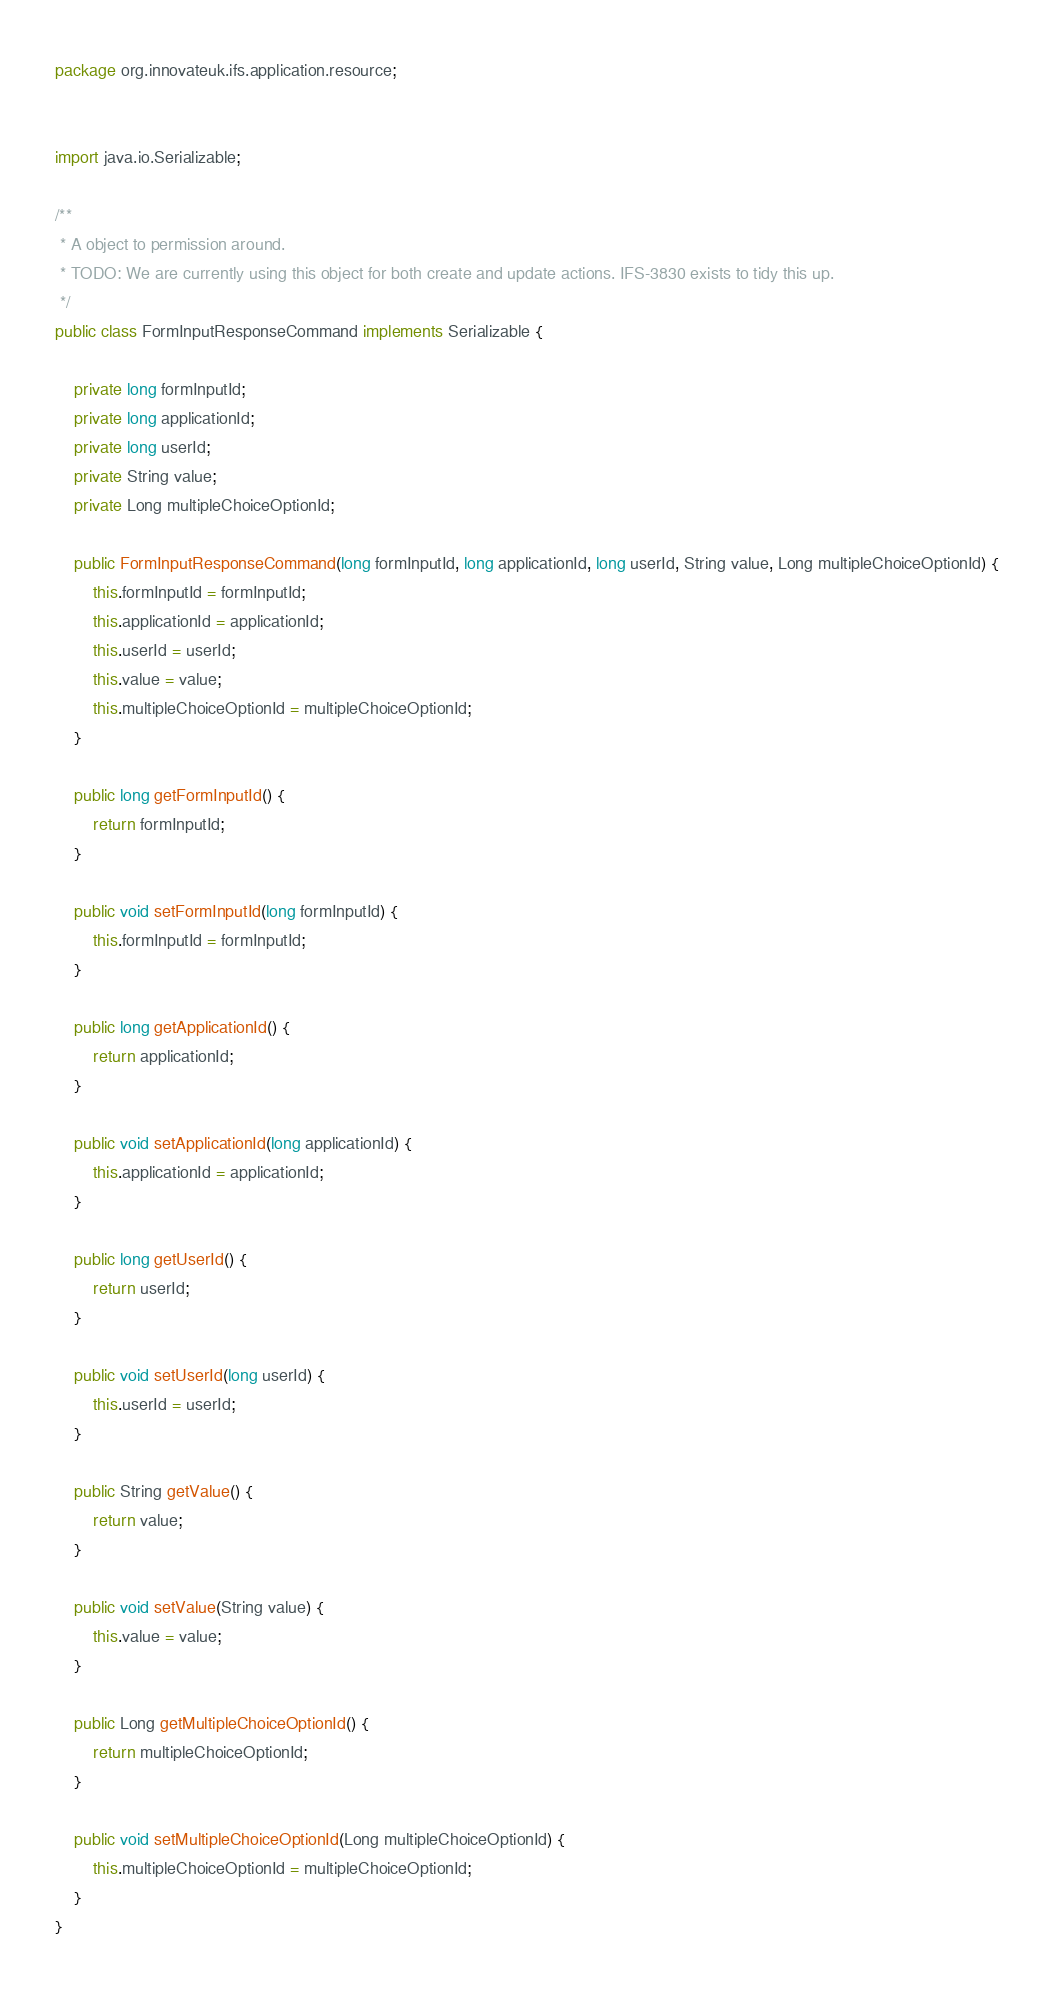Convert code to text. <code><loc_0><loc_0><loc_500><loc_500><_Java_>package org.innovateuk.ifs.application.resource;


import java.io.Serializable;

/**
 * A object to permission around.
 * TODO: We are currently using this object for both create and update actions. IFS-3830 exists to tidy this up.
 */
public class FormInputResponseCommand implements Serializable {

    private long formInputId;
    private long applicationId;
    private long userId;
    private String value;
    private Long multipleChoiceOptionId;

    public FormInputResponseCommand(long formInputId, long applicationId, long userId, String value, Long multipleChoiceOptionId) {
        this.formInputId = formInputId;
        this.applicationId = applicationId;
        this.userId = userId;
        this.value = value;
        this.multipleChoiceOptionId = multipleChoiceOptionId;
    }

    public long getFormInputId() {
        return formInputId;
    }

    public void setFormInputId(long formInputId) {
        this.formInputId = formInputId;
    }

    public long getApplicationId() {
        return applicationId;
    }

    public void setApplicationId(long applicationId) {
        this.applicationId = applicationId;
    }

    public long getUserId() {
        return userId;
    }

    public void setUserId(long userId) {
        this.userId = userId;
    }

    public String getValue() {
        return value;
    }

    public void setValue(String value) {
        this.value = value;
    }

    public Long getMultipleChoiceOptionId() {
        return multipleChoiceOptionId;
    }

    public void setMultipleChoiceOptionId(Long multipleChoiceOptionId) {
        this.multipleChoiceOptionId = multipleChoiceOptionId;
    }
}
</code> 